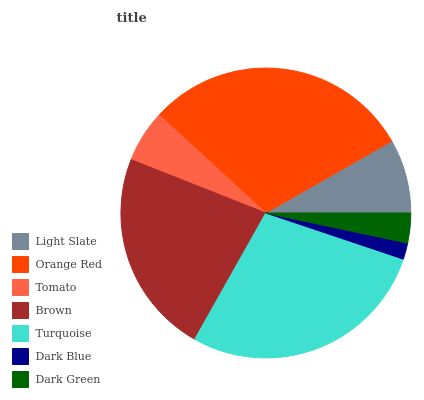Is Dark Blue the minimum?
Answer yes or no. Yes. Is Orange Red the maximum?
Answer yes or no. Yes. Is Tomato the minimum?
Answer yes or no. No. Is Tomato the maximum?
Answer yes or no. No. Is Orange Red greater than Tomato?
Answer yes or no. Yes. Is Tomato less than Orange Red?
Answer yes or no. Yes. Is Tomato greater than Orange Red?
Answer yes or no. No. Is Orange Red less than Tomato?
Answer yes or no. No. Is Light Slate the high median?
Answer yes or no. Yes. Is Light Slate the low median?
Answer yes or no. Yes. Is Dark Green the high median?
Answer yes or no. No. Is Tomato the low median?
Answer yes or no. No. 